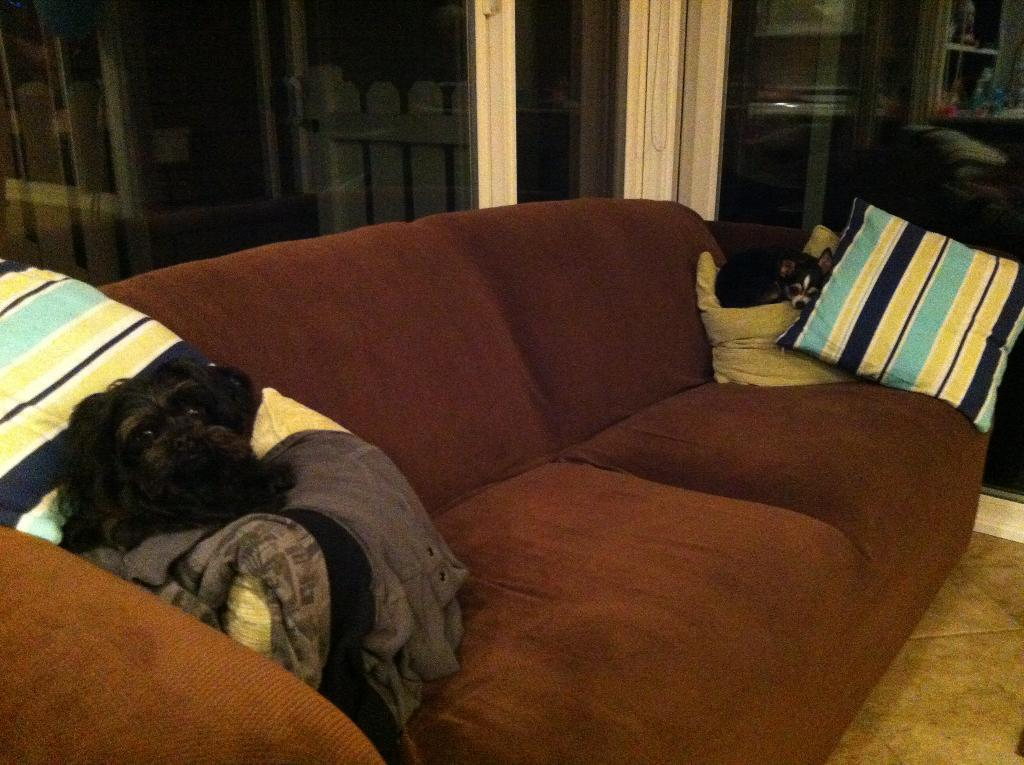What type of furniture is in the image? There is a couch in the image. What animals are present in the image? Two dogs are present in the image. Where are the dogs sitting in the image? The dogs are sitting on the couch. Can you describe the specific location of the dogs on the couch? The dogs are sitting on the cushions of the couch. What type of shop can be seen in the image? There is no shop present in the image; it features a couch with two dogs sitting on the cushions. 